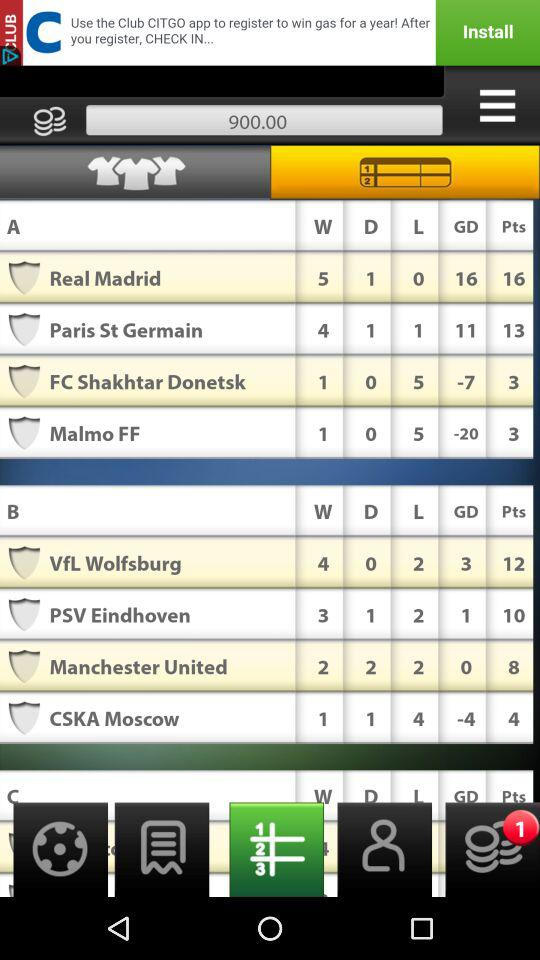What is the score of GD at Real Madrid? The score of GD at Real Madrid is 16. 